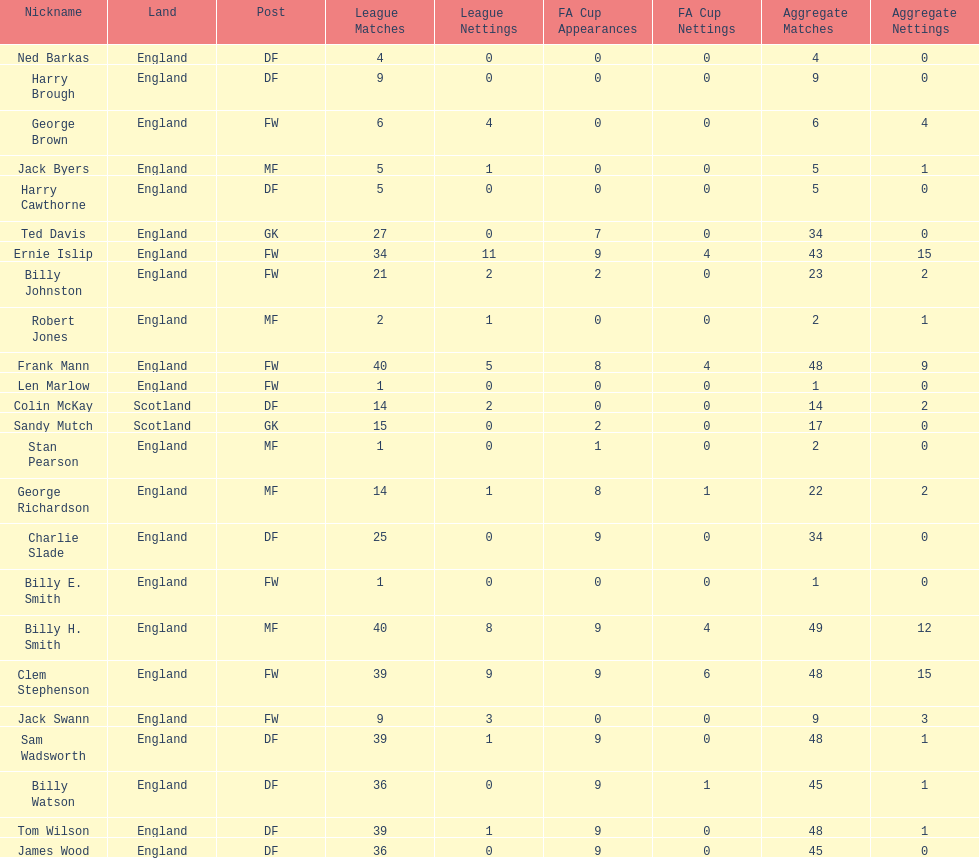What is the primary name noted down? Ned Barkas. 